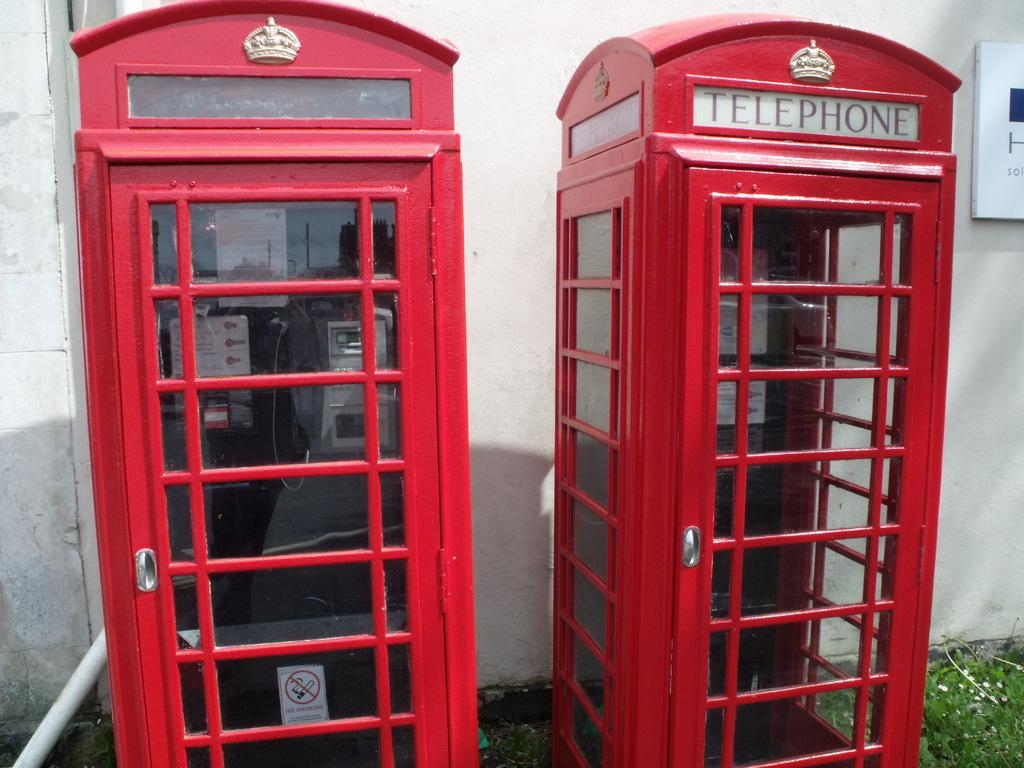<image>
Render a clear and concise summary of the photo. Two red telephone booths stand next to eachother, one with a no smoking sign 